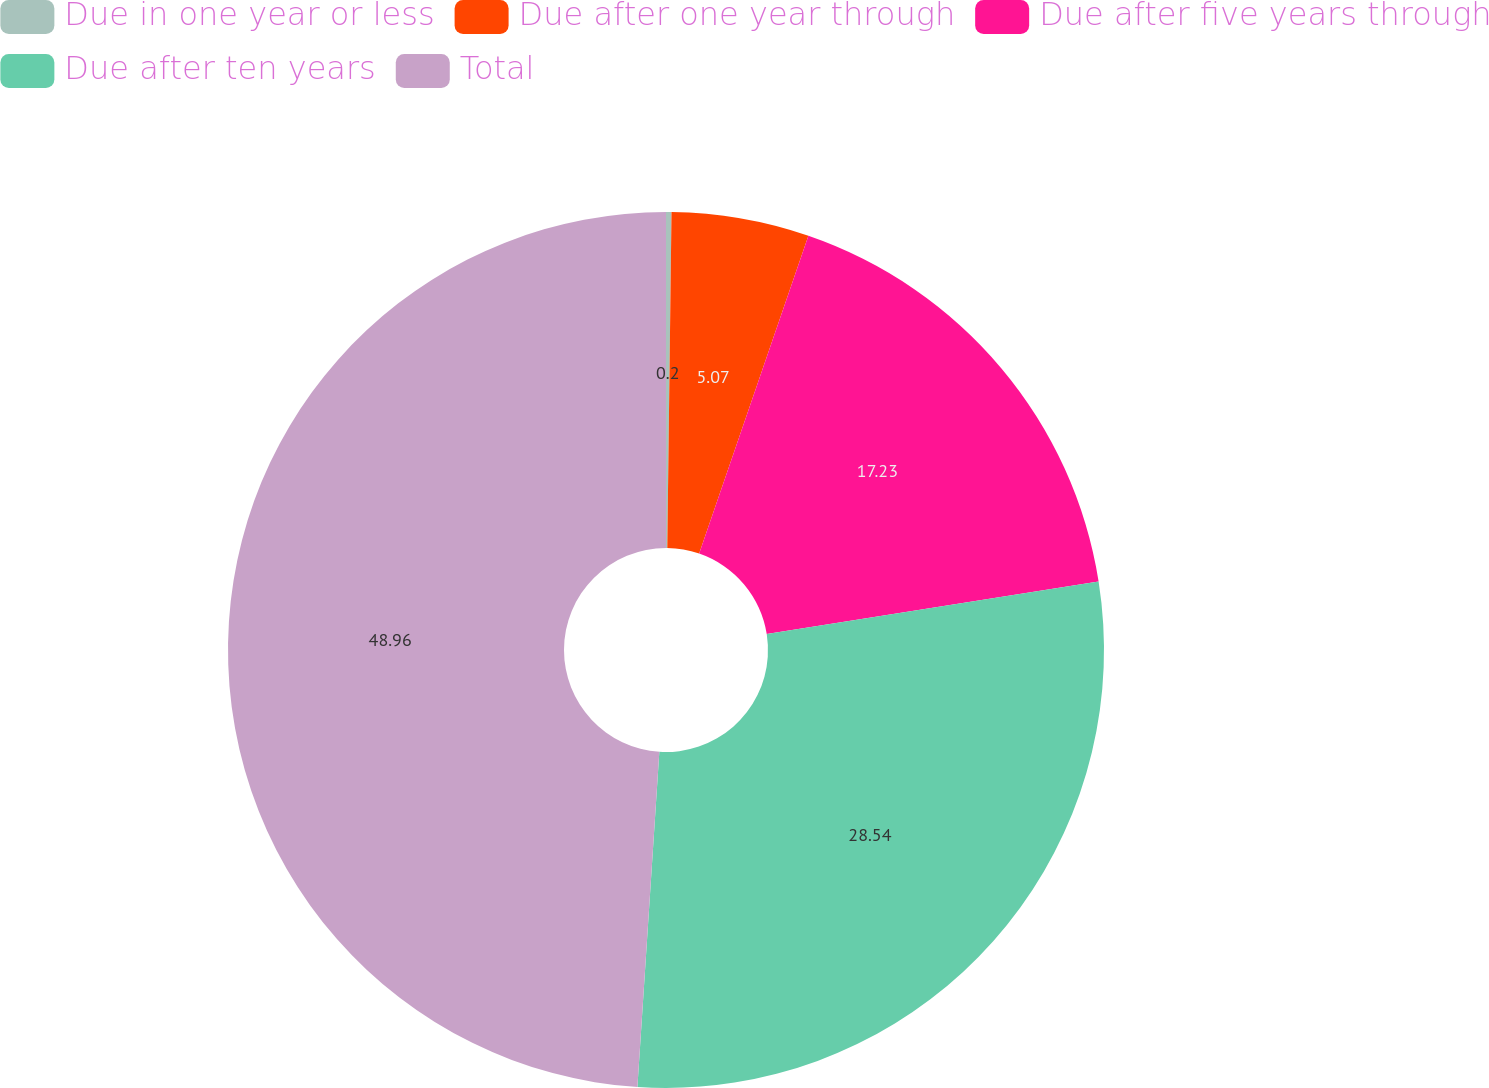Convert chart to OTSL. <chart><loc_0><loc_0><loc_500><loc_500><pie_chart><fcel>Due in one year or less<fcel>Due after one year through<fcel>Due after five years through<fcel>Due after ten years<fcel>Total<nl><fcel>0.2%<fcel>5.07%<fcel>17.23%<fcel>28.54%<fcel>48.96%<nl></chart> 